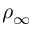<formula> <loc_0><loc_0><loc_500><loc_500>\rho _ { \infty }</formula> 